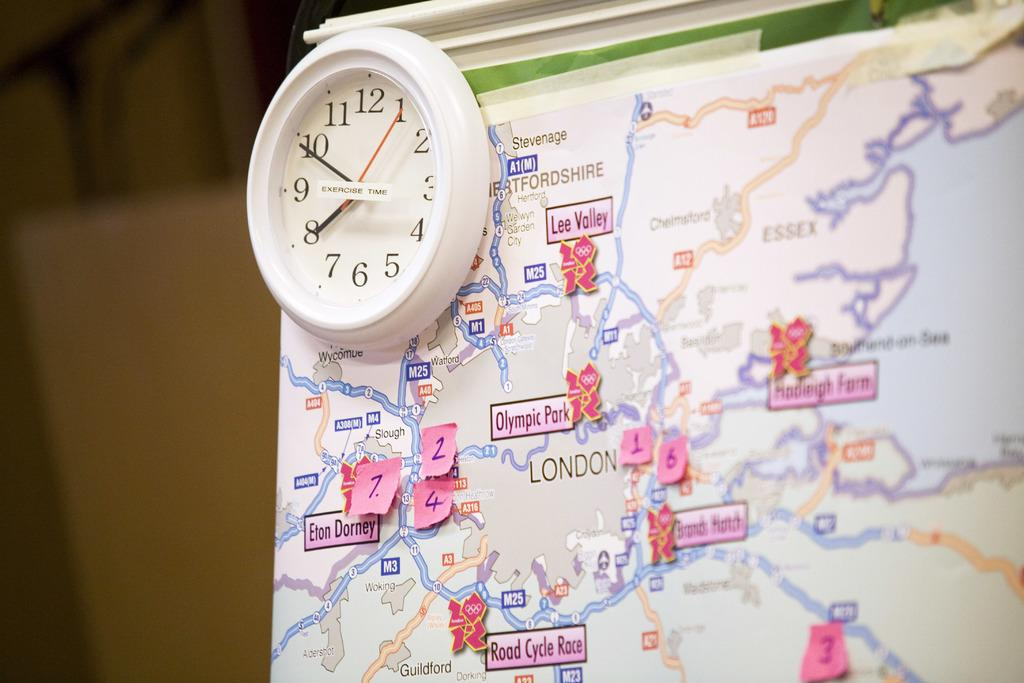<image>
Create a compact narrative representing the image presented. a clock on top of a map that is labeled 'exercise time' 